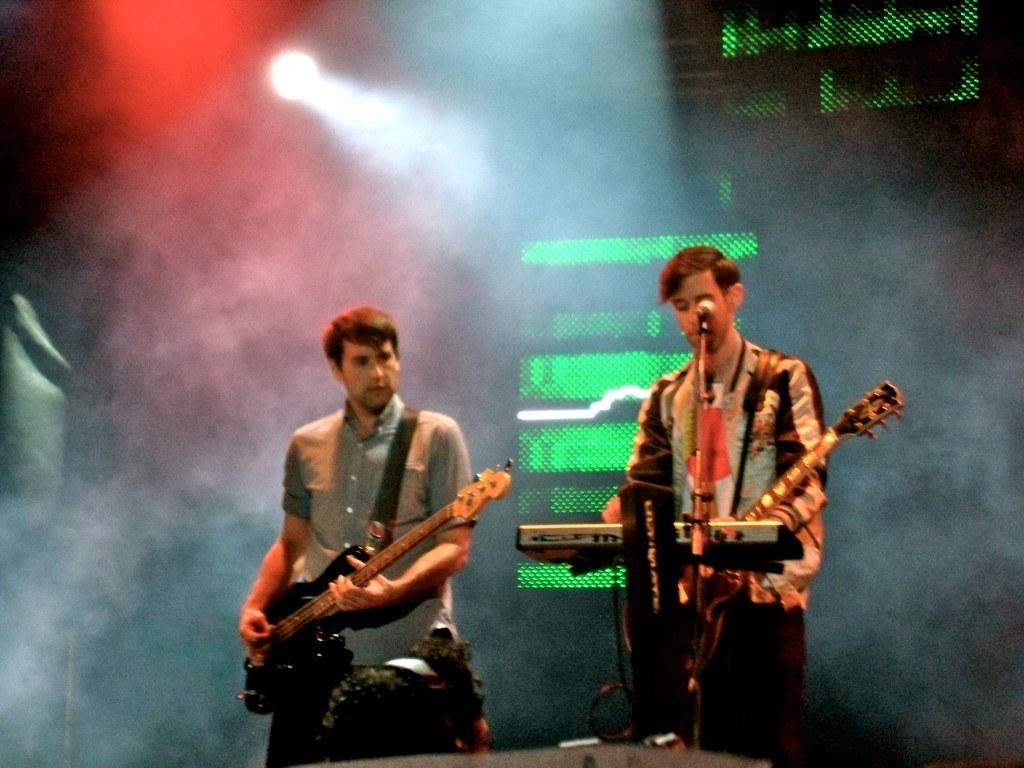How many people are in the image? There are two men in the image. What are the men holding in the image? The men are holding guitars. Can you describe the presence of a microphone in the image? Yes, there is a microphone in front of one of the men. What type of toy can be seen flying in the background of the image? There is no toy or any object flying in the background of the image. What route are the men taking with their guitars in the image? The image does not show the men taking any route with their guitars; they are holding them stationary. 